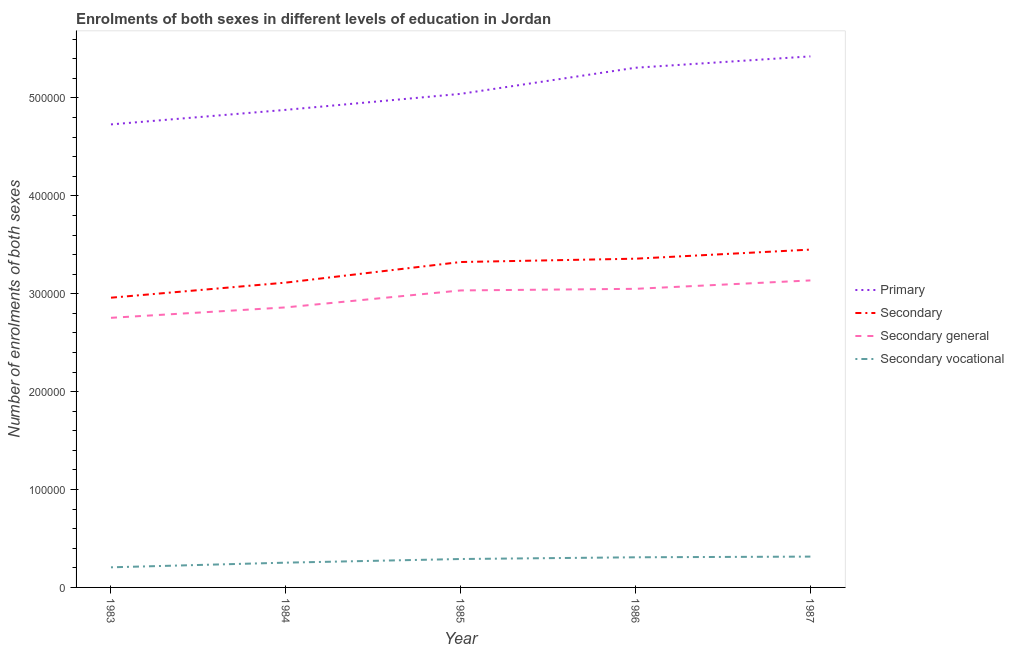How many different coloured lines are there?
Ensure brevity in your answer.  4. What is the number of enrolments in primary education in 1986?
Your response must be concise. 5.31e+05. Across all years, what is the maximum number of enrolments in secondary education?
Offer a terse response. 3.45e+05. Across all years, what is the minimum number of enrolments in secondary vocational education?
Ensure brevity in your answer.  2.05e+04. In which year was the number of enrolments in secondary general education maximum?
Your response must be concise. 1987. In which year was the number of enrolments in secondary vocational education minimum?
Offer a terse response. 1983. What is the total number of enrolments in secondary general education in the graph?
Offer a very short reply. 1.48e+06. What is the difference between the number of enrolments in primary education in 1983 and that in 1984?
Keep it short and to the point. -1.49e+04. What is the difference between the number of enrolments in secondary vocational education in 1984 and the number of enrolments in secondary general education in 1987?
Make the answer very short. -2.88e+05. What is the average number of enrolments in secondary vocational education per year?
Offer a very short reply. 2.74e+04. In the year 1985, what is the difference between the number of enrolments in secondary general education and number of enrolments in secondary education?
Provide a short and direct response. -2.90e+04. In how many years, is the number of enrolments in secondary general education greater than 200000?
Provide a short and direct response. 5. What is the ratio of the number of enrolments in secondary education in 1986 to that in 1987?
Provide a succinct answer. 0.97. Is the number of enrolments in secondary vocational education in 1984 less than that in 1985?
Offer a terse response. Yes. Is the difference between the number of enrolments in secondary vocational education in 1984 and 1985 greater than the difference between the number of enrolments in secondary education in 1984 and 1985?
Your response must be concise. Yes. What is the difference between the highest and the second highest number of enrolments in secondary education?
Your answer should be very brief. 9287. What is the difference between the highest and the lowest number of enrolments in primary education?
Offer a very short reply. 6.95e+04. Is it the case that in every year, the sum of the number of enrolments in secondary education and number of enrolments in secondary vocational education is greater than the sum of number of enrolments in secondary general education and number of enrolments in primary education?
Offer a very short reply. No. Is it the case that in every year, the sum of the number of enrolments in primary education and number of enrolments in secondary education is greater than the number of enrolments in secondary general education?
Offer a terse response. Yes. How many lines are there?
Provide a short and direct response. 4. Are the values on the major ticks of Y-axis written in scientific E-notation?
Offer a terse response. No. Does the graph contain any zero values?
Give a very brief answer. No. Does the graph contain grids?
Offer a terse response. No. Where does the legend appear in the graph?
Offer a very short reply. Center right. How many legend labels are there?
Keep it short and to the point. 4. How are the legend labels stacked?
Offer a terse response. Vertical. What is the title of the graph?
Make the answer very short. Enrolments of both sexes in different levels of education in Jordan. What is the label or title of the Y-axis?
Offer a terse response. Number of enrolments of both sexes. What is the Number of enrolments of both sexes in Primary in 1983?
Give a very brief answer. 4.73e+05. What is the Number of enrolments of both sexes of Secondary in 1983?
Give a very brief answer. 2.96e+05. What is the Number of enrolments of both sexes in Secondary general in 1983?
Provide a short and direct response. 2.75e+05. What is the Number of enrolments of both sexes of Secondary vocational in 1983?
Your response must be concise. 2.05e+04. What is the Number of enrolments of both sexes in Primary in 1984?
Offer a very short reply. 4.88e+05. What is the Number of enrolments of both sexes of Secondary in 1984?
Your response must be concise. 3.11e+05. What is the Number of enrolments of both sexes in Secondary general in 1984?
Provide a succinct answer. 2.86e+05. What is the Number of enrolments of both sexes in Secondary vocational in 1984?
Ensure brevity in your answer.  2.53e+04. What is the Number of enrolments of both sexes in Primary in 1985?
Your answer should be compact. 5.04e+05. What is the Number of enrolments of both sexes of Secondary in 1985?
Your answer should be very brief. 3.32e+05. What is the Number of enrolments of both sexes of Secondary general in 1985?
Ensure brevity in your answer.  3.03e+05. What is the Number of enrolments of both sexes of Secondary vocational in 1985?
Make the answer very short. 2.90e+04. What is the Number of enrolments of both sexes of Primary in 1986?
Offer a very short reply. 5.31e+05. What is the Number of enrolments of both sexes in Secondary in 1986?
Provide a succinct answer. 3.36e+05. What is the Number of enrolments of both sexes of Secondary general in 1986?
Provide a succinct answer. 3.05e+05. What is the Number of enrolments of both sexes of Secondary vocational in 1986?
Give a very brief answer. 3.08e+04. What is the Number of enrolments of both sexes of Primary in 1987?
Make the answer very short. 5.43e+05. What is the Number of enrolments of both sexes of Secondary in 1987?
Give a very brief answer. 3.45e+05. What is the Number of enrolments of both sexes in Secondary general in 1987?
Provide a succinct answer. 3.14e+05. What is the Number of enrolments of both sexes of Secondary vocational in 1987?
Your answer should be compact. 3.15e+04. Across all years, what is the maximum Number of enrolments of both sexes of Primary?
Provide a short and direct response. 5.43e+05. Across all years, what is the maximum Number of enrolments of both sexes in Secondary?
Offer a very short reply. 3.45e+05. Across all years, what is the maximum Number of enrolments of both sexes of Secondary general?
Your answer should be very brief. 3.14e+05. Across all years, what is the maximum Number of enrolments of both sexes of Secondary vocational?
Your answer should be compact. 3.15e+04. Across all years, what is the minimum Number of enrolments of both sexes in Primary?
Provide a short and direct response. 4.73e+05. Across all years, what is the minimum Number of enrolments of both sexes of Secondary?
Provide a short and direct response. 2.96e+05. Across all years, what is the minimum Number of enrolments of both sexes in Secondary general?
Provide a short and direct response. 2.75e+05. Across all years, what is the minimum Number of enrolments of both sexes in Secondary vocational?
Offer a very short reply. 2.05e+04. What is the total Number of enrolments of both sexes in Primary in the graph?
Give a very brief answer. 2.54e+06. What is the total Number of enrolments of both sexes in Secondary in the graph?
Give a very brief answer. 1.62e+06. What is the total Number of enrolments of both sexes of Secondary general in the graph?
Offer a terse response. 1.48e+06. What is the total Number of enrolments of both sexes of Secondary vocational in the graph?
Your answer should be very brief. 1.37e+05. What is the difference between the Number of enrolments of both sexes of Primary in 1983 and that in 1984?
Provide a succinct answer. -1.49e+04. What is the difference between the Number of enrolments of both sexes of Secondary in 1983 and that in 1984?
Ensure brevity in your answer.  -1.54e+04. What is the difference between the Number of enrolments of both sexes of Secondary general in 1983 and that in 1984?
Provide a succinct answer. -1.07e+04. What is the difference between the Number of enrolments of both sexes of Secondary vocational in 1983 and that in 1984?
Your answer should be very brief. -4761. What is the difference between the Number of enrolments of both sexes of Primary in 1983 and that in 1985?
Offer a terse response. -3.12e+04. What is the difference between the Number of enrolments of both sexes in Secondary in 1983 and that in 1985?
Your answer should be very brief. -3.64e+04. What is the difference between the Number of enrolments of both sexes in Secondary general in 1983 and that in 1985?
Give a very brief answer. -2.80e+04. What is the difference between the Number of enrolments of both sexes in Secondary vocational in 1983 and that in 1985?
Give a very brief answer. -8477. What is the difference between the Number of enrolments of both sexes of Primary in 1983 and that in 1986?
Make the answer very short. -5.79e+04. What is the difference between the Number of enrolments of both sexes of Secondary in 1983 and that in 1986?
Ensure brevity in your answer.  -3.98e+04. What is the difference between the Number of enrolments of both sexes of Secondary general in 1983 and that in 1986?
Give a very brief answer. -2.96e+04. What is the difference between the Number of enrolments of both sexes in Secondary vocational in 1983 and that in 1986?
Make the answer very short. -1.02e+04. What is the difference between the Number of enrolments of both sexes of Primary in 1983 and that in 1987?
Offer a very short reply. -6.95e+04. What is the difference between the Number of enrolments of both sexes in Secondary in 1983 and that in 1987?
Make the answer very short. -4.91e+04. What is the difference between the Number of enrolments of both sexes in Secondary general in 1983 and that in 1987?
Your answer should be very brief. -3.82e+04. What is the difference between the Number of enrolments of both sexes in Secondary vocational in 1983 and that in 1987?
Ensure brevity in your answer.  -1.09e+04. What is the difference between the Number of enrolments of both sexes in Primary in 1984 and that in 1985?
Provide a short and direct response. -1.63e+04. What is the difference between the Number of enrolments of both sexes of Secondary in 1984 and that in 1985?
Provide a short and direct response. -2.10e+04. What is the difference between the Number of enrolments of both sexes of Secondary general in 1984 and that in 1985?
Your response must be concise. -1.73e+04. What is the difference between the Number of enrolments of both sexes in Secondary vocational in 1984 and that in 1985?
Ensure brevity in your answer.  -3716. What is the difference between the Number of enrolments of both sexes of Primary in 1984 and that in 1986?
Your answer should be very brief. -4.30e+04. What is the difference between the Number of enrolments of both sexes of Secondary in 1984 and that in 1986?
Provide a short and direct response. -2.44e+04. What is the difference between the Number of enrolments of both sexes in Secondary general in 1984 and that in 1986?
Offer a terse response. -1.90e+04. What is the difference between the Number of enrolments of both sexes of Secondary vocational in 1984 and that in 1986?
Provide a short and direct response. -5479. What is the difference between the Number of enrolments of both sexes in Primary in 1984 and that in 1987?
Your response must be concise. -5.46e+04. What is the difference between the Number of enrolments of both sexes in Secondary in 1984 and that in 1987?
Your response must be concise. -3.37e+04. What is the difference between the Number of enrolments of both sexes in Secondary general in 1984 and that in 1987?
Ensure brevity in your answer.  -2.75e+04. What is the difference between the Number of enrolments of both sexes in Secondary vocational in 1984 and that in 1987?
Your response must be concise. -6183. What is the difference between the Number of enrolments of both sexes in Primary in 1985 and that in 1986?
Provide a succinct answer. -2.67e+04. What is the difference between the Number of enrolments of both sexes in Secondary in 1985 and that in 1986?
Offer a terse response. -3405. What is the difference between the Number of enrolments of both sexes of Secondary general in 1985 and that in 1986?
Provide a short and direct response. -1642. What is the difference between the Number of enrolments of both sexes of Secondary vocational in 1985 and that in 1986?
Your answer should be very brief. -1763. What is the difference between the Number of enrolments of both sexes in Primary in 1985 and that in 1987?
Provide a short and direct response. -3.83e+04. What is the difference between the Number of enrolments of both sexes in Secondary in 1985 and that in 1987?
Give a very brief answer. -1.27e+04. What is the difference between the Number of enrolments of both sexes in Secondary general in 1985 and that in 1987?
Offer a terse response. -1.02e+04. What is the difference between the Number of enrolments of both sexes of Secondary vocational in 1985 and that in 1987?
Your response must be concise. -2467. What is the difference between the Number of enrolments of both sexes in Primary in 1986 and that in 1987?
Provide a succinct answer. -1.16e+04. What is the difference between the Number of enrolments of both sexes in Secondary in 1986 and that in 1987?
Your response must be concise. -9287. What is the difference between the Number of enrolments of both sexes of Secondary general in 1986 and that in 1987?
Keep it short and to the point. -8583. What is the difference between the Number of enrolments of both sexes in Secondary vocational in 1986 and that in 1987?
Your response must be concise. -704. What is the difference between the Number of enrolments of both sexes of Primary in 1983 and the Number of enrolments of both sexes of Secondary in 1984?
Give a very brief answer. 1.62e+05. What is the difference between the Number of enrolments of both sexes in Primary in 1983 and the Number of enrolments of both sexes in Secondary general in 1984?
Provide a succinct answer. 1.87e+05. What is the difference between the Number of enrolments of both sexes of Primary in 1983 and the Number of enrolments of both sexes of Secondary vocational in 1984?
Offer a very short reply. 4.48e+05. What is the difference between the Number of enrolments of both sexes in Secondary in 1983 and the Number of enrolments of both sexes in Secondary general in 1984?
Your answer should be very brief. 9897. What is the difference between the Number of enrolments of both sexes of Secondary in 1983 and the Number of enrolments of both sexes of Secondary vocational in 1984?
Your answer should be very brief. 2.71e+05. What is the difference between the Number of enrolments of both sexes in Secondary general in 1983 and the Number of enrolments of both sexes in Secondary vocational in 1984?
Give a very brief answer. 2.50e+05. What is the difference between the Number of enrolments of both sexes of Primary in 1983 and the Number of enrolments of both sexes of Secondary in 1985?
Your response must be concise. 1.41e+05. What is the difference between the Number of enrolments of both sexes of Primary in 1983 and the Number of enrolments of both sexes of Secondary general in 1985?
Provide a succinct answer. 1.70e+05. What is the difference between the Number of enrolments of both sexes in Primary in 1983 and the Number of enrolments of both sexes in Secondary vocational in 1985?
Make the answer very short. 4.44e+05. What is the difference between the Number of enrolments of both sexes in Secondary in 1983 and the Number of enrolments of both sexes in Secondary general in 1985?
Offer a terse response. -7415. What is the difference between the Number of enrolments of both sexes of Secondary in 1983 and the Number of enrolments of both sexes of Secondary vocational in 1985?
Keep it short and to the point. 2.67e+05. What is the difference between the Number of enrolments of both sexes of Secondary general in 1983 and the Number of enrolments of both sexes of Secondary vocational in 1985?
Your answer should be compact. 2.46e+05. What is the difference between the Number of enrolments of both sexes of Primary in 1983 and the Number of enrolments of both sexes of Secondary in 1986?
Your response must be concise. 1.37e+05. What is the difference between the Number of enrolments of both sexes in Primary in 1983 and the Number of enrolments of both sexes in Secondary general in 1986?
Make the answer very short. 1.68e+05. What is the difference between the Number of enrolments of both sexes of Primary in 1983 and the Number of enrolments of both sexes of Secondary vocational in 1986?
Your response must be concise. 4.42e+05. What is the difference between the Number of enrolments of both sexes of Secondary in 1983 and the Number of enrolments of both sexes of Secondary general in 1986?
Your answer should be compact. -9057. What is the difference between the Number of enrolments of both sexes in Secondary in 1983 and the Number of enrolments of both sexes in Secondary vocational in 1986?
Offer a very short reply. 2.65e+05. What is the difference between the Number of enrolments of both sexes in Secondary general in 1983 and the Number of enrolments of both sexes in Secondary vocational in 1986?
Offer a terse response. 2.45e+05. What is the difference between the Number of enrolments of both sexes of Primary in 1983 and the Number of enrolments of both sexes of Secondary in 1987?
Provide a short and direct response. 1.28e+05. What is the difference between the Number of enrolments of both sexes of Primary in 1983 and the Number of enrolments of both sexes of Secondary general in 1987?
Keep it short and to the point. 1.59e+05. What is the difference between the Number of enrolments of both sexes of Primary in 1983 and the Number of enrolments of both sexes of Secondary vocational in 1987?
Ensure brevity in your answer.  4.42e+05. What is the difference between the Number of enrolments of both sexes in Secondary in 1983 and the Number of enrolments of both sexes in Secondary general in 1987?
Provide a succinct answer. -1.76e+04. What is the difference between the Number of enrolments of both sexes in Secondary in 1983 and the Number of enrolments of both sexes in Secondary vocational in 1987?
Ensure brevity in your answer.  2.64e+05. What is the difference between the Number of enrolments of both sexes of Secondary general in 1983 and the Number of enrolments of both sexes of Secondary vocational in 1987?
Your response must be concise. 2.44e+05. What is the difference between the Number of enrolments of both sexes of Primary in 1984 and the Number of enrolments of both sexes of Secondary in 1985?
Offer a terse response. 1.55e+05. What is the difference between the Number of enrolments of both sexes of Primary in 1984 and the Number of enrolments of both sexes of Secondary general in 1985?
Ensure brevity in your answer.  1.84e+05. What is the difference between the Number of enrolments of both sexes of Primary in 1984 and the Number of enrolments of both sexes of Secondary vocational in 1985?
Offer a very short reply. 4.59e+05. What is the difference between the Number of enrolments of both sexes of Secondary in 1984 and the Number of enrolments of both sexes of Secondary general in 1985?
Give a very brief answer. 7998. What is the difference between the Number of enrolments of both sexes in Secondary in 1984 and the Number of enrolments of both sexes in Secondary vocational in 1985?
Offer a very short reply. 2.82e+05. What is the difference between the Number of enrolments of both sexes in Secondary general in 1984 and the Number of enrolments of both sexes in Secondary vocational in 1985?
Make the answer very short. 2.57e+05. What is the difference between the Number of enrolments of both sexes of Primary in 1984 and the Number of enrolments of both sexes of Secondary in 1986?
Keep it short and to the point. 1.52e+05. What is the difference between the Number of enrolments of both sexes in Primary in 1984 and the Number of enrolments of both sexes in Secondary general in 1986?
Your answer should be very brief. 1.83e+05. What is the difference between the Number of enrolments of both sexes of Primary in 1984 and the Number of enrolments of both sexes of Secondary vocational in 1986?
Give a very brief answer. 4.57e+05. What is the difference between the Number of enrolments of both sexes in Secondary in 1984 and the Number of enrolments of both sexes in Secondary general in 1986?
Give a very brief answer. 6356. What is the difference between the Number of enrolments of both sexes in Secondary in 1984 and the Number of enrolments of both sexes in Secondary vocational in 1986?
Keep it short and to the point. 2.81e+05. What is the difference between the Number of enrolments of both sexes of Secondary general in 1984 and the Number of enrolments of both sexes of Secondary vocational in 1986?
Keep it short and to the point. 2.55e+05. What is the difference between the Number of enrolments of both sexes of Primary in 1984 and the Number of enrolments of both sexes of Secondary in 1987?
Offer a terse response. 1.43e+05. What is the difference between the Number of enrolments of both sexes of Primary in 1984 and the Number of enrolments of both sexes of Secondary general in 1987?
Your response must be concise. 1.74e+05. What is the difference between the Number of enrolments of both sexes in Primary in 1984 and the Number of enrolments of both sexes in Secondary vocational in 1987?
Ensure brevity in your answer.  4.56e+05. What is the difference between the Number of enrolments of both sexes in Secondary in 1984 and the Number of enrolments of both sexes in Secondary general in 1987?
Offer a very short reply. -2227. What is the difference between the Number of enrolments of both sexes of Secondary in 1984 and the Number of enrolments of both sexes of Secondary vocational in 1987?
Ensure brevity in your answer.  2.80e+05. What is the difference between the Number of enrolments of both sexes in Secondary general in 1984 and the Number of enrolments of both sexes in Secondary vocational in 1987?
Provide a succinct answer. 2.55e+05. What is the difference between the Number of enrolments of both sexes of Primary in 1985 and the Number of enrolments of both sexes of Secondary in 1986?
Ensure brevity in your answer.  1.68e+05. What is the difference between the Number of enrolments of both sexes in Primary in 1985 and the Number of enrolments of both sexes in Secondary general in 1986?
Ensure brevity in your answer.  1.99e+05. What is the difference between the Number of enrolments of both sexes of Primary in 1985 and the Number of enrolments of both sexes of Secondary vocational in 1986?
Provide a succinct answer. 4.73e+05. What is the difference between the Number of enrolments of both sexes in Secondary in 1985 and the Number of enrolments of both sexes in Secondary general in 1986?
Make the answer very short. 2.74e+04. What is the difference between the Number of enrolments of both sexes of Secondary in 1985 and the Number of enrolments of both sexes of Secondary vocational in 1986?
Provide a succinct answer. 3.02e+05. What is the difference between the Number of enrolments of both sexes of Secondary general in 1985 and the Number of enrolments of both sexes of Secondary vocational in 1986?
Your answer should be very brief. 2.73e+05. What is the difference between the Number of enrolments of both sexes in Primary in 1985 and the Number of enrolments of both sexes in Secondary in 1987?
Offer a very short reply. 1.59e+05. What is the difference between the Number of enrolments of both sexes in Primary in 1985 and the Number of enrolments of both sexes in Secondary general in 1987?
Offer a terse response. 1.91e+05. What is the difference between the Number of enrolments of both sexes of Primary in 1985 and the Number of enrolments of both sexes of Secondary vocational in 1987?
Your answer should be compact. 4.73e+05. What is the difference between the Number of enrolments of both sexes in Secondary in 1985 and the Number of enrolments of both sexes in Secondary general in 1987?
Keep it short and to the point. 1.88e+04. What is the difference between the Number of enrolments of both sexes in Secondary in 1985 and the Number of enrolments of both sexes in Secondary vocational in 1987?
Provide a short and direct response. 3.01e+05. What is the difference between the Number of enrolments of both sexes of Secondary general in 1985 and the Number of enrolments of both sexes of Secondary vocational in 1987?
Keep it short and to the point. 2.72e+05. What is the difference between the Number of enrolments of both sexes in Primary in 1986 and the Number of enrolments of both sexes in Secondary in 1987?
Keep it short and to the point. 1.86e+05. What is the difference between the Number of enrolments of both sexes of Primary in 1986 and the Number of enrolments of both sexes of Secondary general in 1987?
Keep it short and to the point. 2.17e+05. What is the difference between the Number of enrolments of both sexes in Primary in 1986 and the Number of enrolments of both sexes in Secondary vocational in 1987?
Your answer should be very brief. 4.99e+05. What is the difference between the Number of enrolments of both sexes of Secondary in 1986 and the Number of enrolments of both sexes of Secondary general in 1987?
Your response must be concise. 2.22e+04. What is the difference between the Number of enrolments of both sexes of Secondary in 1986 and the Number of enrolments of both sexes of Secondary vocational in 1987?
Provide a succinct answer. 3.04e+05. What is the difference between the Number of enrolments of both sexes of Secondary general in 1986 and the Number of enrolments of both sexes of Secondary vocational in 1987?
Your answer should be compact. 2.74e+05. What is the average Number of enrolments of both sexes of Primary per year?
Your answer should be compact. 5.08e+05. What is the average Number of enrolments of both sexes of Secondary per year?
Provide a short and direct response. 3.24e+05. What is the average Number of enrolments of both sexes of Secondary general per year?
Provide a short and direct response. 2.97e+05. What is the average Number of enrolments of both sexes in Secondary vocational per year?
Your answer should be very brief. 2.74e+04. In the year 1983, what is the difference between the Number of enrolments of both sexes in Primary and Number of enrolments of both sexes in Secondary?
Your answer should be compact. 1.77e+05. In the year 1983, what is the difference between the Number of enrolments of both sexes of Primary and Number of enrolments of both sexes of Secondary general?
Ensure brevity in your answer.  1.98e+05. In the year 1983, what is the difference between the Number of enrolments of both sexes in Primary and Number of enrolments of both sexes in Secondary vocational?
Your answer should be very brief. 4.52e+05. In the year 1983, what is the difference between the Number of enrolments of both sexes in Secondary and Number of enrolments of both sexes in Secondary general?
Your answer should be compact. 2.05e+04. In the year 1983, what is the difference between the Number of enrolments of both sexes of Secondary and Number of enrolments of both sexes of Secondary vocational?
Offer a very short reply. 2.75e+05. In the year 1983, what is the difference between the Number of enrolments of both sexes of Secondary general and Number of enrolments of both sexes of Secondary vocational?
Provide a succinct answer. 2.55e+05. In the year 1984, what is the difference between the Number of enrolments of both sexes in Primary and Number of enrolments of both sexes in Secondary?
Give a very brief answer. 1.76e+05. In the year 1984, what is the difference between the Number of enrolments of both sexes in Primary and Number of enrolments of both sexes in Secondary general?
Your response must be concise. 2.02e+05. In the year 1984, what is the difference between the Number of enrolments of both sexes in Primary and Number of enrolments of both sexes in Secondary vocational?
Keep it short and to the point. 4.63e+05. In the year 1984, what is the difference between the Number of enrolments of both sexes in Secondary and Number of enrolments of both sexes in Secondary general?
Make the answer very short. 2.53e+04. In the year 1984, what is the difference between the Number of enrolments of both sexes of Secondary and Number of enrolments of both sexes of Secondary vocational?
Provide a succinct answer. 2.86e+05. In the year 1984, what is the difference between the Number of enrolments of both sexes of Secondary general and Number of enrolments of both sexes of Secondary vocational?
Offer a terse response. 2.61e+05. In the year 1985, what is the difference between the Number of enrolments of both sexes of Primary and Number of enrolments of both sexes of Secondary?
Give a very brief answer. 1.72e+05. In the year 1985, what is the difference between the Number of enrolments of both sexes of Primary and Number of enrolments of both sexes of Secondary general?
Keep it short and to the point. 2.01e+05. In the year 1985, what is the difference between the Number of enrolments of both sexes of Primary and Number of enrolments of both sexes of Secondary vocational?
Your answer should be compact. 4.75e+05. In the year 1985, what is the difference between the Number of enrolments of both sexes in Secondary and Number of enrolments of both sexes in Secondary general?
Keep it short and to the point. 2.90e+04. In the year 1985, what is the difference between the Number of enrolments of both sexes in Secondary and Number of enrolments of both sexes in Secondary vocational?
Your answer should be very brief. 3.03e+05. In the year 1985, what is the difference between the Number of enrolments of both sexes of Secondary general and Number of enrolments of both sexes of Secondary vocational?
Give a very brief answer. 2.74e+05. In the year 1986, what is the difference between the Number of enrolments of both sexes of Primary and Number of enrolments of both sexes of Secondary?
Provide a short and direct response. 1.95e+05. In the year 1986, what is the difference between the Number of enrolments of both sexes in Primary and Number of enrolments of both sexes in Secondary general?
Offer a very short reply. 2.26e+05. In the year 1986, what is the difference between the Number of enrolments of both sexes of Primary and Number of enrolments of both sexes of Secondary vocational?
Give a very brief answer. 5.00e+05. In the year 1986, what is the difference between the Number of enrolments of both sexes in Secondary and Number of enrolments of both sexes in Secondary general?
Keep it short and to the point. 3.08e+04. In the year 1986, what is the difference between the Number of enrolments of both sexes in Secondary and Number of enrolments of both sexes in Secondary vocational?
Keep it short and to the point. 3.05e+05. In the year 1986, what is the difference between the Number of enrolments of both sexes of Secondary general and Number of enrolments of both sexes of Secondary vocational?
Your answer should be very brief. 2.74e+05. In the year 1987, what is the difference between the Number of enrolments of both sexes in Primary and Number of enrolments of both sexes in Secondary?
Give a very brief answer. 1.97e+05. In the year 1987, what is the difference between the Number of enrolments of both sexes of Primary and Number of enrolments of both sexes of Secondary general?
Provide a short and direct response. 2.29e+05. In the year 1987, what is the difference between the Number of enrolments of both sexes in Primary and Number of enrolments of both sexes in Secondary vocational?
Your answer should be very brief. 5.11e+05. In the year 1987, what is the difference between the Number of enrolments of both sexes in Secondary and Number of enrolments of both sexes in Secondary general?
Your response must be concise. 3.15e+04. In the year 1987, what is the difference between the Number of enrolments of both sexes in Secondary and Number of enrolments of both sexes in Secondary vocational?
Offer a terse response. 3.14e+05. In the year 1987, what is the difference between the Number of enrolments of both sexes of Secondary general and Number of enrolments of both sexes of Secondary vocational?
Offer a very short reply. 2.82e+05. What is the ratio of the Number of enrolments of both sexes in Primary in 1983 to that in 1984?
Your answer should be very brief. 0.97. What is the ratio of the Number of enrolments of both sexes in Secondary in 1983 to that in 1984?
Offer a terse response. 0.95. What is the ratio of the Number of enrolments of both sexes of Secondary general in 1983 to that in 1984?
Keep it short and to the point. 0.96. What is the ratio of the Number of enrolments of both sexes in Secondary vocational in 1983 to that in 1984?
Keep it short and to the point. 0.81. What is the ratio of the Number of enrolments of both sexes of Primary in 1983 to that in 1985?
Offer a very short reply. 0.94. What is the ratio of the Number of enrolments of both sexes in Secondary in 1983 to that in 1985?
Offer a terse response. 0.89. What is the ratio of the Number of enrolments of both sexes of Secondary general in 1983 to that in 1985?
Give a very brief answer. 0.91. What is the ratio of the Number of enrolments of both sexes in Secondary vocational in 1983 to that in 1985?
Your answer should be compact. 0.71. What is the ratio of the Number of enrolments of both sexes of Primary in 1983 to that in 1986?
Keep it short and to the point. 0.89. What is the ratio of the Number of enrolments of both sexes in Secondary in 1983 to that in 1986?
Offer a terse response. 0.88. What is the ratio of the Number of enrolments of both sexes in Secondary general in 1983 to that in 1986?
Offer a very short reply. 0.9. What is the ratio of the Number of enrolments of both sexes of Secondary vocational in 1983 to that in 1986?
Offer a very short reply. 0.67. What is the ratio of the Number of enrolments of both sexes in Primary in 1983 to that in 1987?
Keep it short and to the point. 0.87. What is the ratio of the Number of enrolments of both sexes of Secondary in 1983 to that in 1987?
Keep it short and to the point. 0.86. What is the ratio of the Number of enrolments of both sexes in Secondary general in 1983 to that in 1987?
Offer a very short reply. 0.88. What is the ratio of the Number of enrolments of both sexes of Secondary vocational in 1983 to that in 1987?
Provide a succinct answer. 0.65. What is the ratio of the Number of enrolments of both sexes in Primary in 1984 to that in 1985?
Keep it short and to the point. 0.97. What is the ratio of the Number of enrolments of both sexes in Secondary in 1984 to that in 1985?
Provide a short and direct response. 0.94. What is the ratio of the Number of enrolments of both sexes in Secondary general in 1984 to that in 1985?
Your answer should be very brief. 0.94. What is the ratio of the Number of enrolments of both sexes of Secondary vocational in 1984 to that in 1985?
Offer a terse response. 0.87. What is the ratio of the Number of enrolments of both sexes of Primary in 1984 to that in 1986?
Provide a short and direct response. 0.92. What is the ratio of the Number of enrolments of both sexes of Secondary in 1984 to that in 1986?
Provide a succinct answer. 0.93. What is the ratio of the Number of enrolments of both sexes of Secondary general in 1984 to that in 1986?
Ensure brevity in your answer.  0.94. What is the ratio of the Number of enrolments of both sexes in Secondary vocational in 1984 to that in 1986?
Ensure brevity in your answer.  0.82. What is the ratio of the Number of enrolments of both sexes of Primary in 1984 to that in 1987?
Your answer should be very brief. 0.9. What is the ratio of the Number of enrolments of both sexes in Secondary in 1984 to that in 1987?
Make the answer very short. 0.9. What is the ratio of the Number of enrolments of both sexes of Secondary general in 1984 to that in 1987?
Make the answer very short. 0.91. What is the ratio of the Number of enrolments of both sexes in Secondary vocational in 1984 to that in 1987?
Your answer should be compact. 0.8. What is the ratio of the Number of enrolments of both sexes of Primary in 1985 to that in 1986?
Keep it short and to the point. 0.95. What is the ratio of the Number of enrolments of both sexes of Secondary in 1985 to that in 1986?
Offer a very short reply. 0.99. What is the ratio of the Number of enrolments of both sexes of Secondary general in 1985 to that in 1986?
Give a very brief answer. 0.99. What is the ratio of the Number of enrolments of both sexes in Secondary vocational in 1985 to that in 1986?
Give a very brief answer. 0.94. What is the ratio of the Number of enrolments of both sexes in Primary in 1985 to that in 1987?
Make the answer very short. 0.93. What is the ratio of the Number of enrolments of both sexes of Secondary in 1985 to that in 1987?
Ensure brevity in your answer.  0.96. What is the ratio of the Number of enrolments of both sexes in Secondary general in 1985 to that in 1987?
Give a very brief answer. 0.97. What is the ratio of the Number of enrolments of both sexes of Secondary vocational in 1985 to that in 1987?
Provide a succinct answer. 0.92. What is the ratio of the Number of enrolments of both sexes in Primary in 1986 to that in 1987?
Offer a terse response. 0.98. What is the ratio of the Number of enrolments of both sexes in Secondary in 1986 to that in 1987?
Ensure brevity in your answer.  0.97. What is the ratio of the Number of enrolments of both sexes of Secondary general in 1986 to that in 1987?
Give a very brief answer. 0.97. What is the ratio of the Number of enrolments of both sexes of Secondary vocational in 1986 to that in 1987?
Your answer should be compact. 0.98. What is the difference between the highest and the second highest Number of enrolments of both sexes of Primary?
Provide a short and direct response. 1.16e+04. What is the difference between the highest and the second highest Number of enrolments of both sexes in Secondary?
Make the answer very short. 9287. What is the difference between the highest and the second highest Number of enrolments of both sexes in Secondary general?
Ensure brevity in your answer.  8583. What is the difference between the highest and the second highest Number of enrolments of both sexes in Secondary vocational?
Provide a short and direct response. 704. What is the difference between the highest and the lowest Number of enrolments of both sexes of Primary?
Offer a terse response. 6.95e+04. What is the difference between the highest and the lowest Number of enrolments of both sexes in Secondary?
Your answer should be very brief. 4.91e+04. What is the difference between the highest and the lowest Number of enrolments of both sexes of Secondary general?
Give a very brief answer. 3.82e+04. What is the difference between the highest and the lowest Number of enrolments of both sexes of Secondary vocational?
Provide a succinct answer. 1.09e+04. 